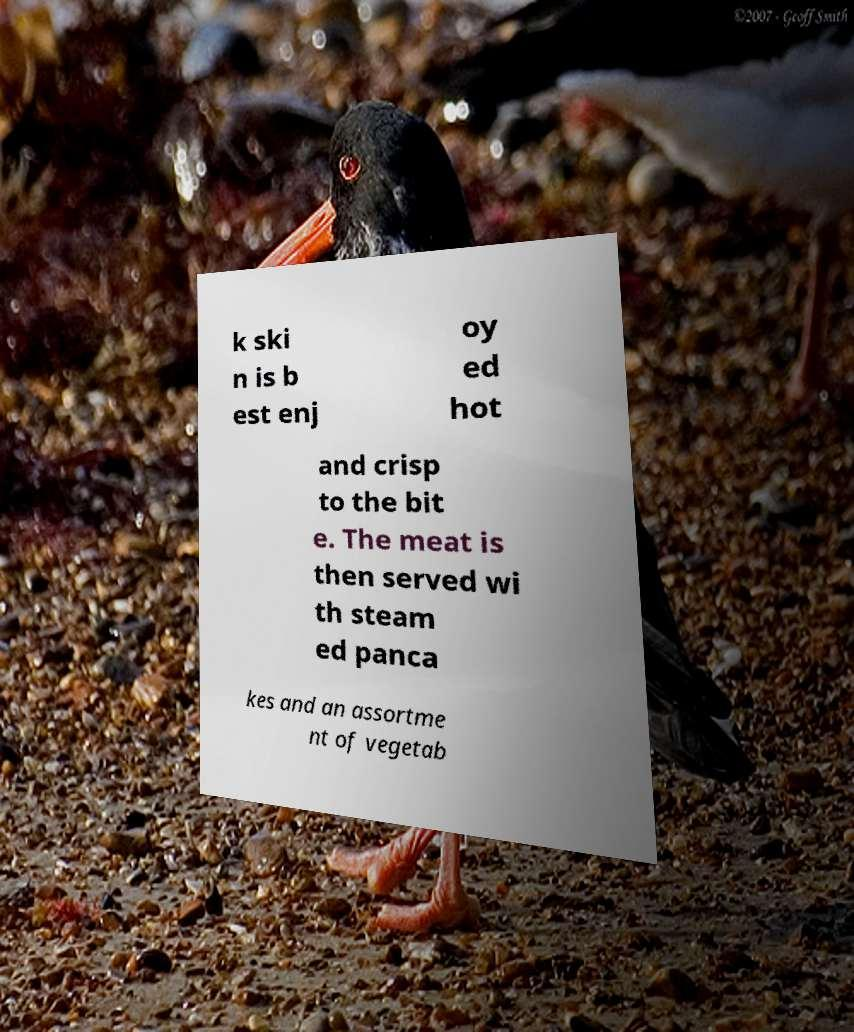Could you assist in decoding the text presented in this image and type it out clearly? k ski n is b est enj oy ed hot and crisp to the bit e. The meat is then served wi th steam ed panca kes and an assortme nt of vegetab 